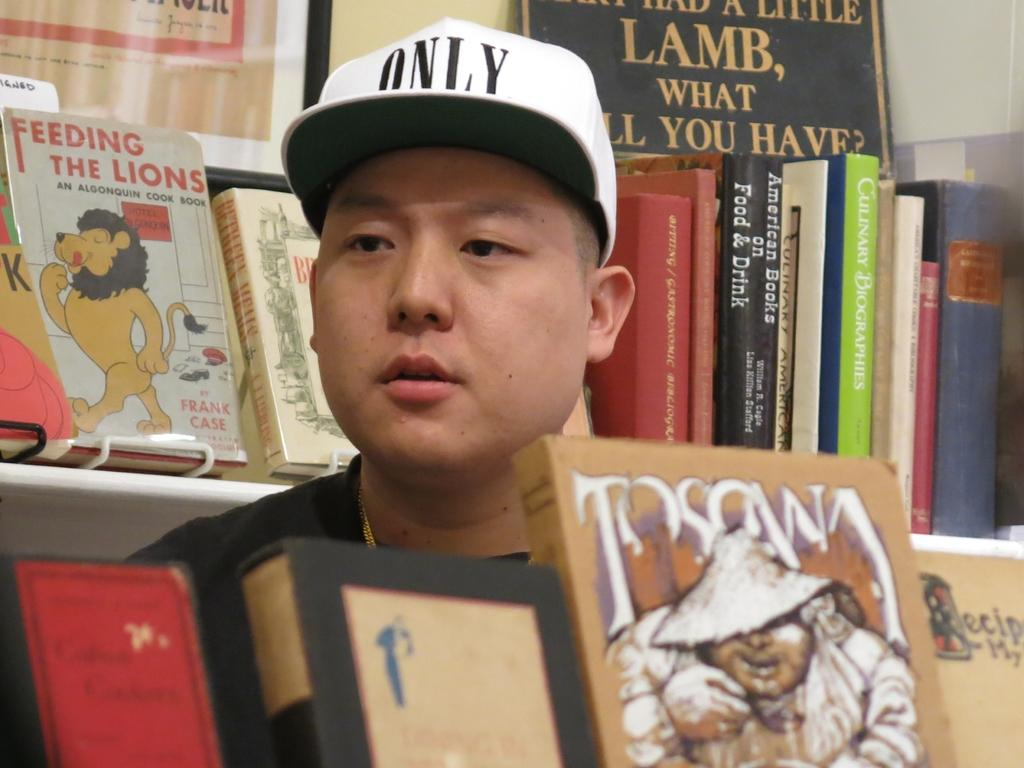<image>
Render a clear and concise summary of the photo. A man in a bookstore with a white hat on that says only. 